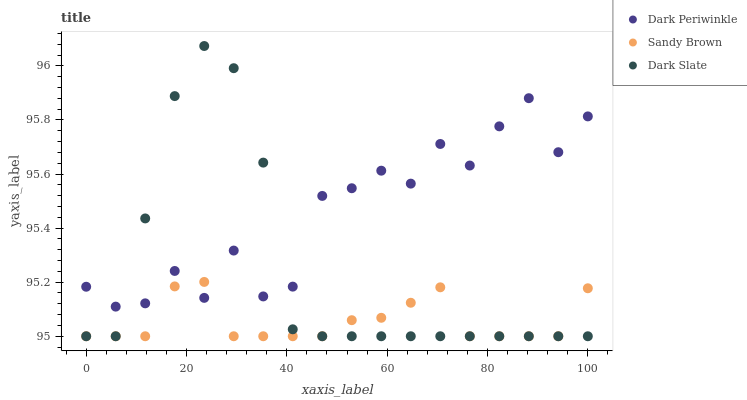Does Sandy Brown have the minimum area under the curve?
Answer yes or no. Yes. Does Dark Periwinkle have the maximum area under the curve?
Answer yes or no. Yes. Does Dark Periwinkle have the minimum area under the curve?
Answer yes or no. No. Does Sandy Brown have the maximum area under the curve?
Answer yes or no. No. Is Sandy Brown the smoothest?
Answer yes or no. Yes. Is Dark Periwinkle the roughest?
Answer yes or no. Yes. Is Dark Periwinkle the smoothest?
Answer yes or no. No. Is Sandy Brown the roughest?
Answer yes or no. No. Does Dark Slate have the lowest value?
Answer yes or no. Yes. Does Dark Periwinkle have the lowest value?
Answer yes or no. No. Does Dark Slate have the highest value?
Answer yes or no. Yes. Does Dark Periwinkle have the highest value?
Answer yes or no. No. Does Sandy Brown intersect Dark Slate?
Answer yes or no. Yes. Is Sandy Brown less than Dark Slate?
Answer yes or no. No. Is Sandy Brown greater than Dark Slate?
Answer yes or no. No. 